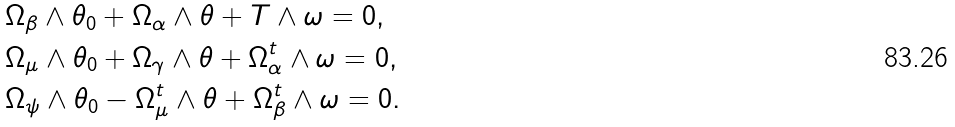Convert formula to latex. <formula><loc_0><loc_0><loc_500><loc_500>& \Omega _ { \beta } \wedge \theta _ { 0 } + \Omega _ { \alpha } \wedge \theta + T \wedge \omega = 0 , \\ & \Omega _ { \mu } \wedge \theta _ { 0 } + \Omega _ { \gamma } \wedge \theta + \Omega _ { \alpha } ^ { t } \wedge \omega = 0 , \\ & \Omega _ { \psi } \wedge \theta _ { 0 } - \Omega _ { \mu } ^ { t } \wedge \theta + \Omega _ { \beta } ^ { t } \wedge \omega = 0 .</formula> 